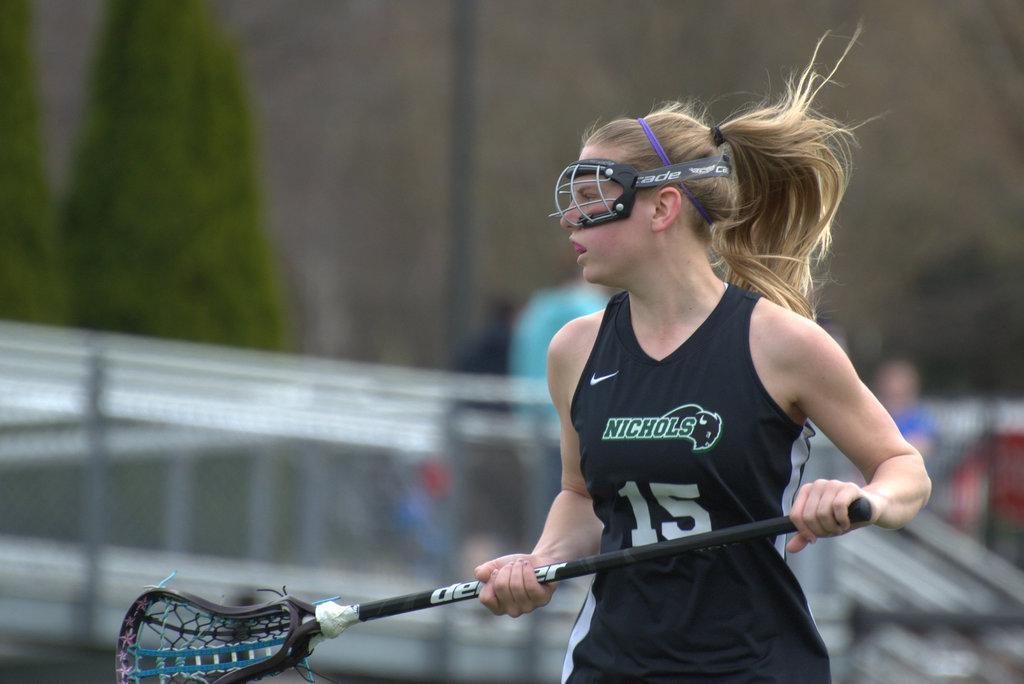Can you describe this image briefly? In the center of the image, we can see a lady wearing a mask and holding a stick. In the background, we can see railings and trees and some people and a wall. 